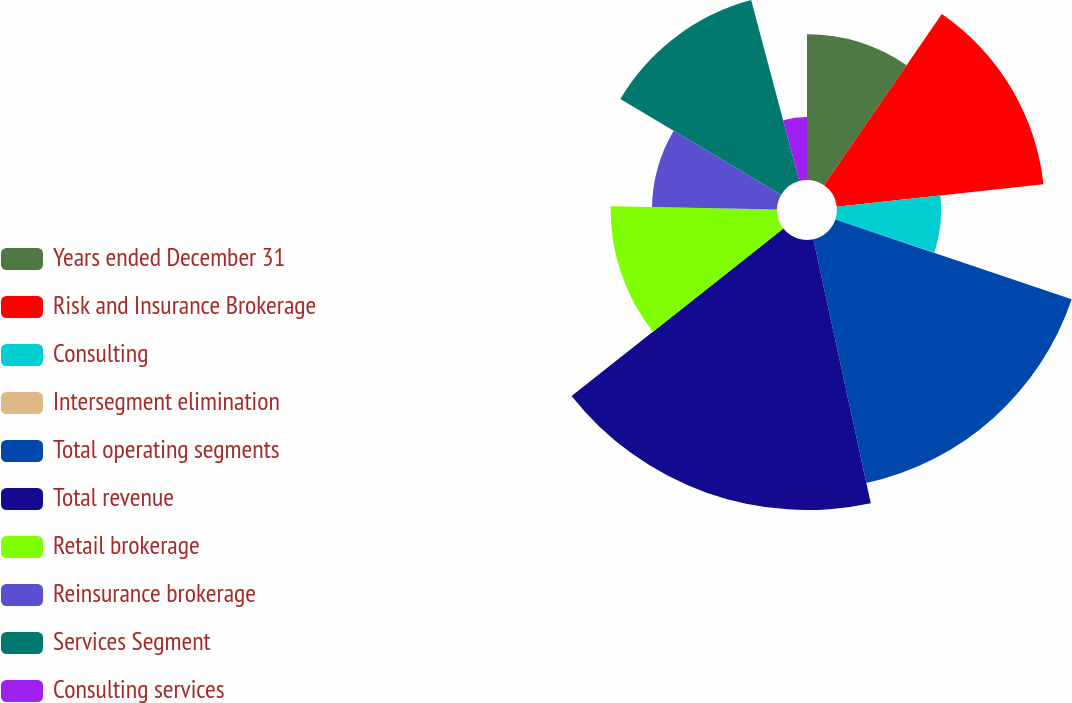<chart> <loc_0><loc_0><loc_500><loc_500><pie_chart><fcel>Years ended December 31<fcel>Risk and Insurance Brokerage<fcel>Consulting<fcel>Intersegment elimination<fcel>Total operating segments<fcel>Total revenue<fcel>Retail brokerage<fcel>Reinsurance brokerage<fcel>Services Segment<fcel>Consulting services<nl><fcel>9.59%<fcel>13.68%<fcel>6.86%<fcel>0.05%<fcel>16.41%<fcel>17.77%<fcel>10.95%<fcel>8.23%<fcel>12.32%<fcel>4.14%<nl></chart> 